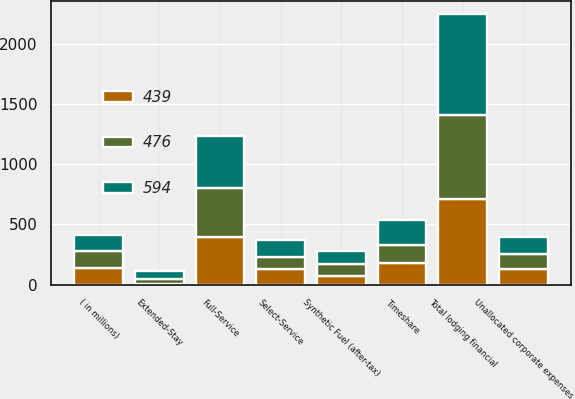Convert chart. <chart><loc_0><loc_0><loc_500><loc_500><stacked_bar_chart><ecel><fcel>( in millions)<fcel>Full-Service<fcel>Select-Service<fcel>Extended-Stay<fcel>Timeshare<fcel>Total lodging financial<fcel>Synthetic Fuel (after-tax)<fcel>Unallocated corporate expenses<nl><fcel>594<fcel>138<fcel>426<fcel>140<fcel>66<fcel>203<fcel>835<fcel>107<fcel>138<nl><fcel>476<fcel>138<fcel>407<fcel>99<fcel>47<fcel>149<fcel>702<fcel>96<fcel>132<nl><fcel>439<fcel>138<fcel>397<fcel>130<fcel>3<fcel>183<fcel>707<fcel>74<fcel>126<nl></chart> 